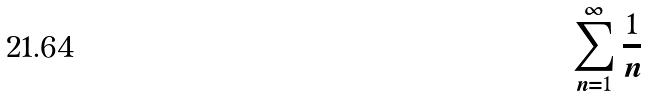<formula> <loc_0><loc_0><loc_500><loc_500>\sum _ { n = 1 } ^ { \infty } \frac { 1 } { n }</formula> 